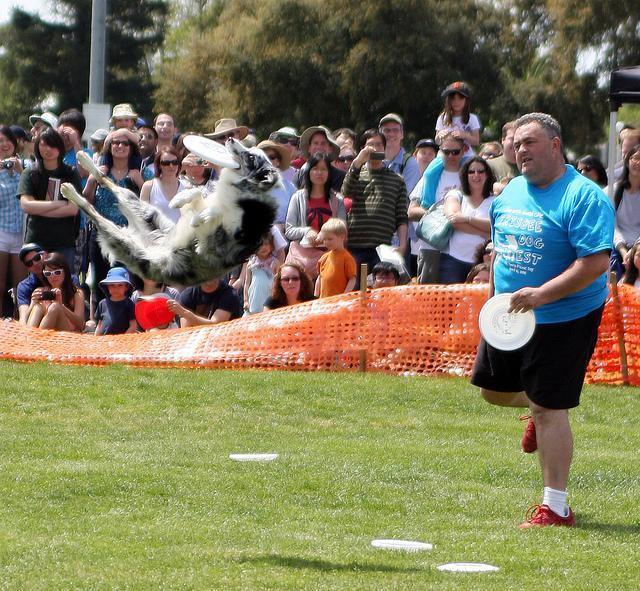How many people can be seen?
Give a very brief answer. 10. 